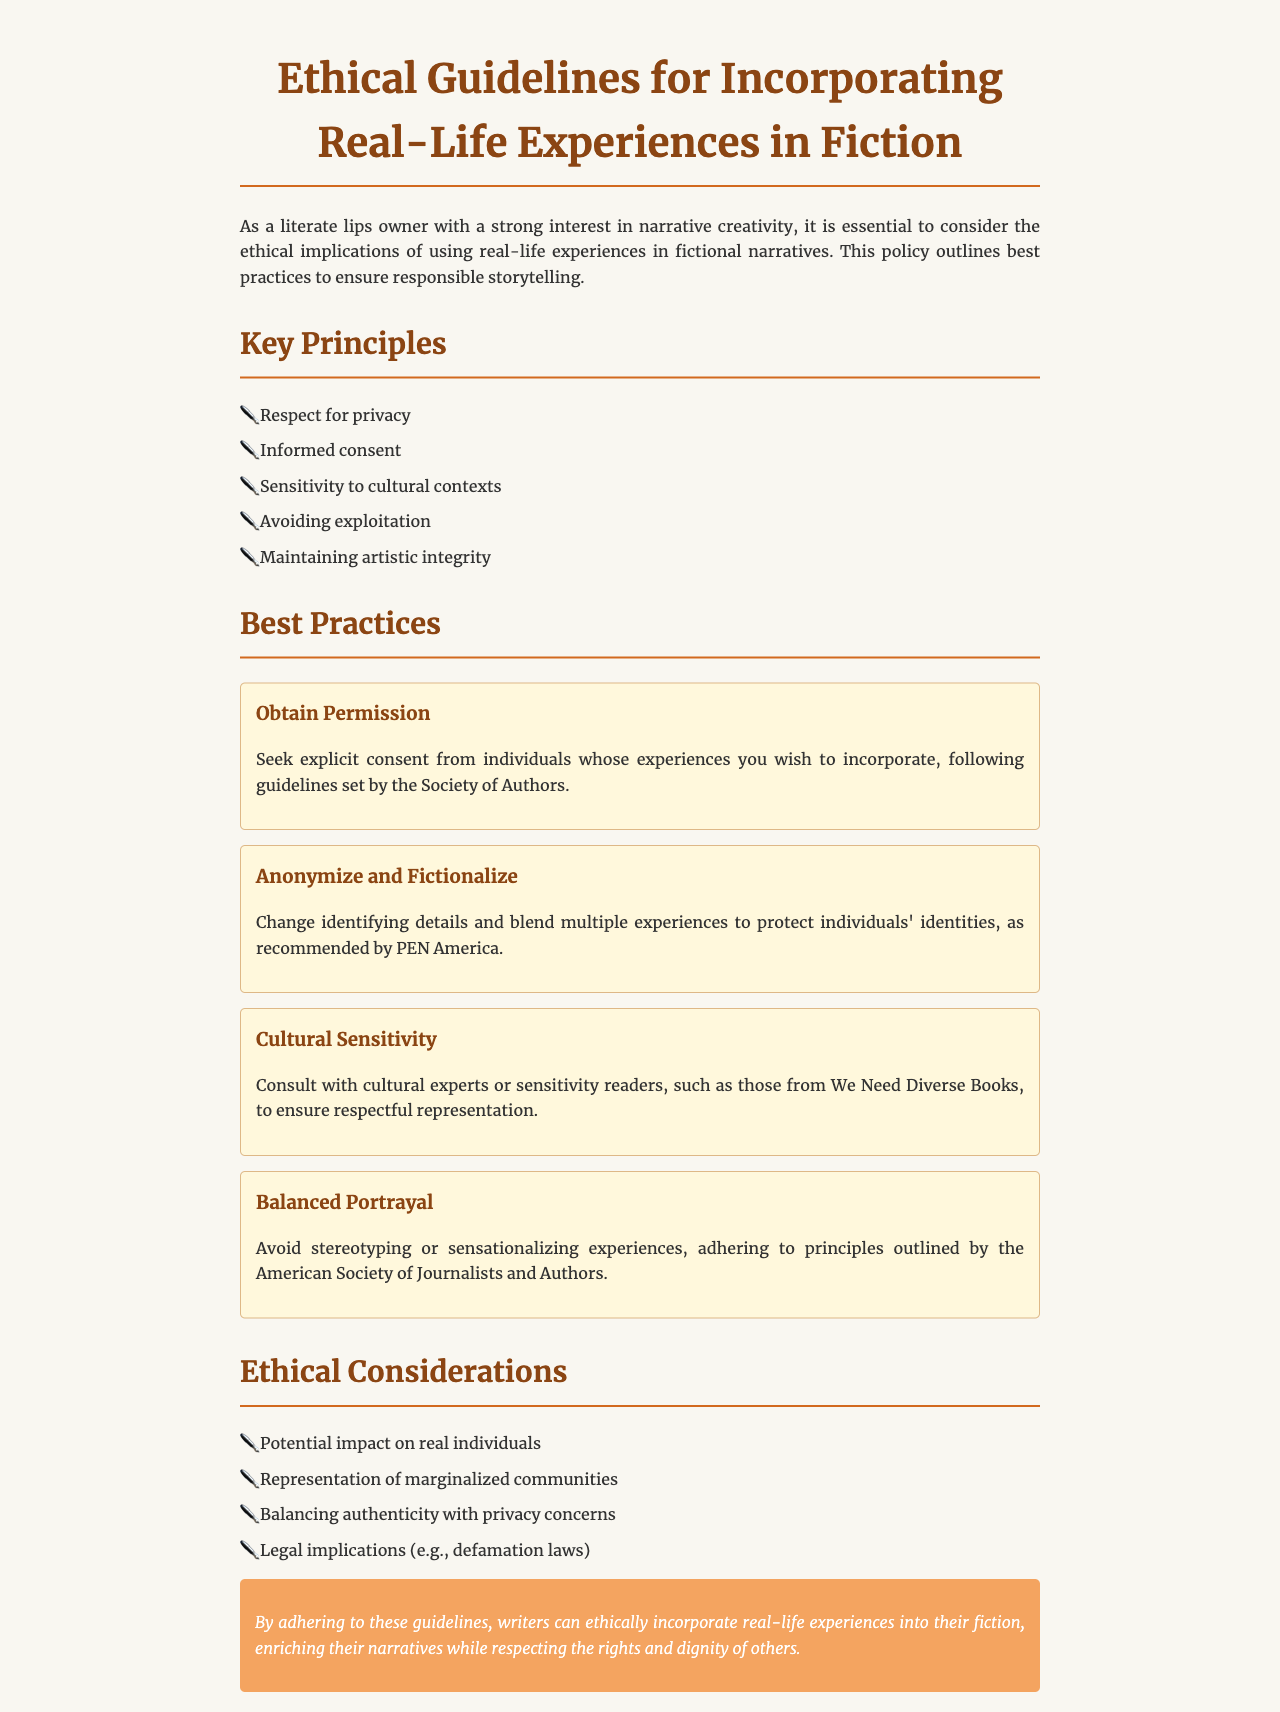What are the key principles outlined in the document? The document lists key principles that include respect for privacy, informed consent, sensitivity to cultural contexts, avoiding exploitation, and maintaining artistic integrity.
Answer: Respect for privacy, informed consent, sensitivity to cultural contexts, avoiding exploitation, maintaining artistic integrity How many best practices are suggested in the document? There are four best practices detailed in the document for incorporating real-life experiences into fiction.
Answer: Four Which organization advises on obtaining permission from individuals? The Society of Authors provides guidelines for seeking explicit consent from individuals whose experiences are incorporated into fiction.
Answer: Society of Authors What should authors do to ensure cultural sensitivity? Authors are advised to consult with cultural experts or sensitivity readers to ensure respectful representation in their narratives.
Answer: Consult with cultural experts or sensitivity readers What ethical consideration involves legal implications? The document mentions balancing authenticity with privacy concerns as one of the ethical considerations that relate to legal implications such as defamation laws.
Answer: Legal implications (e.g., defamation laws) What is the concluding statement of the document emphasizing? The conclusion emphasizes the importance of adhering to the guidelines for ethically incorporating real-life experiences into fiction while respecting rights and dignity.
Answer: Respecting the rights and dignity of others 